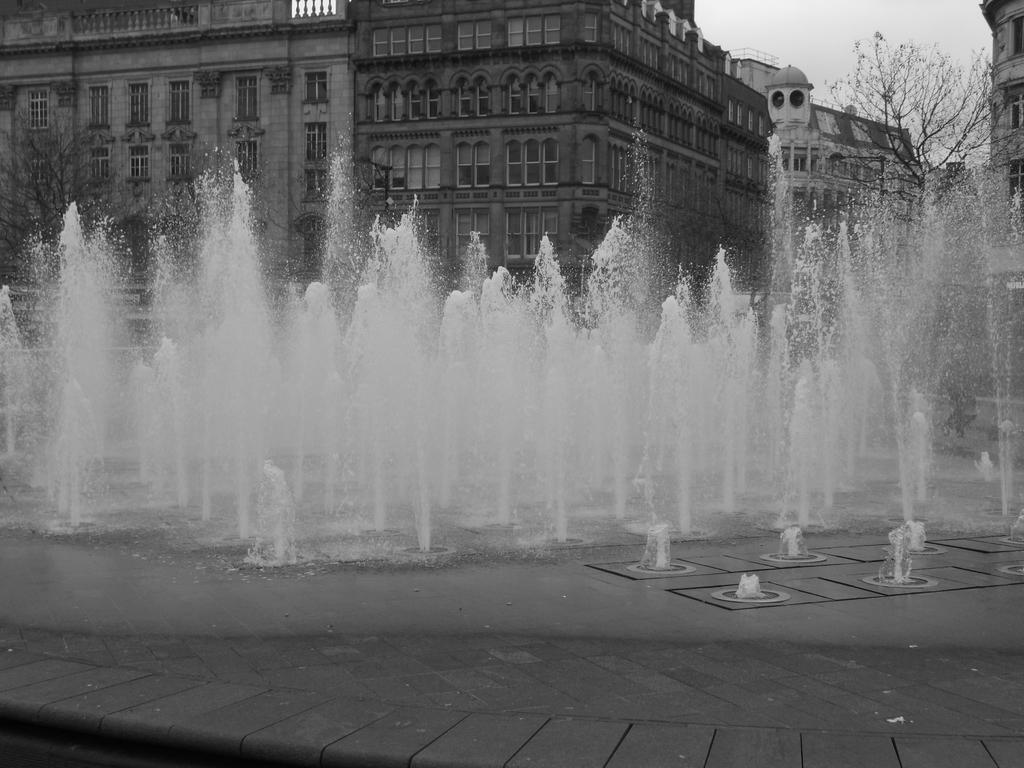What is the main feature in the image? There are water fountains in the image. What can be seen in the background of the image? There are trees and buildings in the background of the image. What is visible at the top of the image? The sky is visible at the top of the image. How many flowers are growing in the middle of the water fountains? There are no flowers present in the image, as it features water fountains and not a garden. Can you spot any lizards climbing on the trees in the background? There are no lizards visible in the image; only trees and buildings can be seen in the background. 